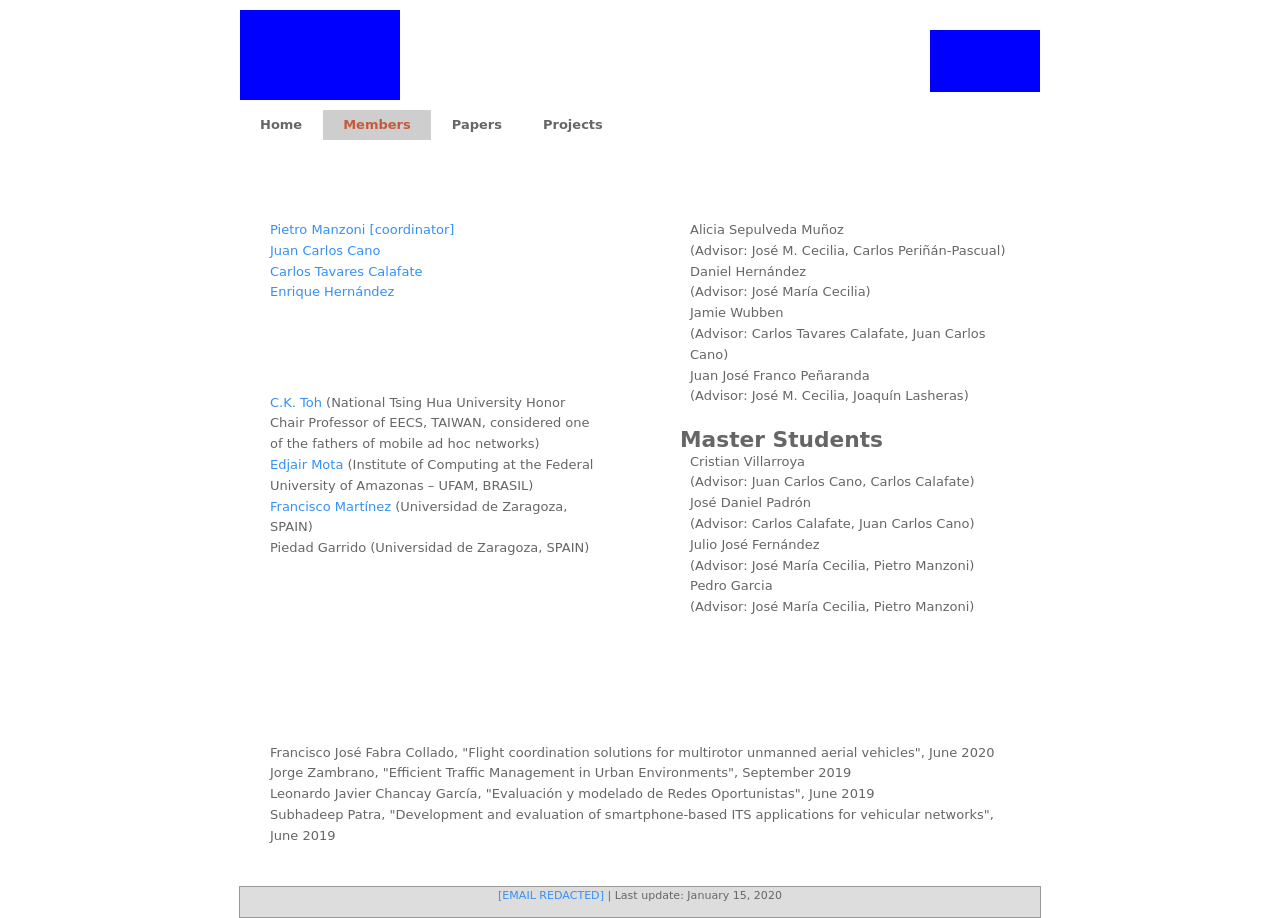What kind of projects are typically undertaken by the members listed on this web page? The members on this webpage likely participate in various academic and research projects related to computer networks and mobile ad hoc networks. These might include developing new communication protocols, researching network security, or exploring efficient data transmission techniques. 